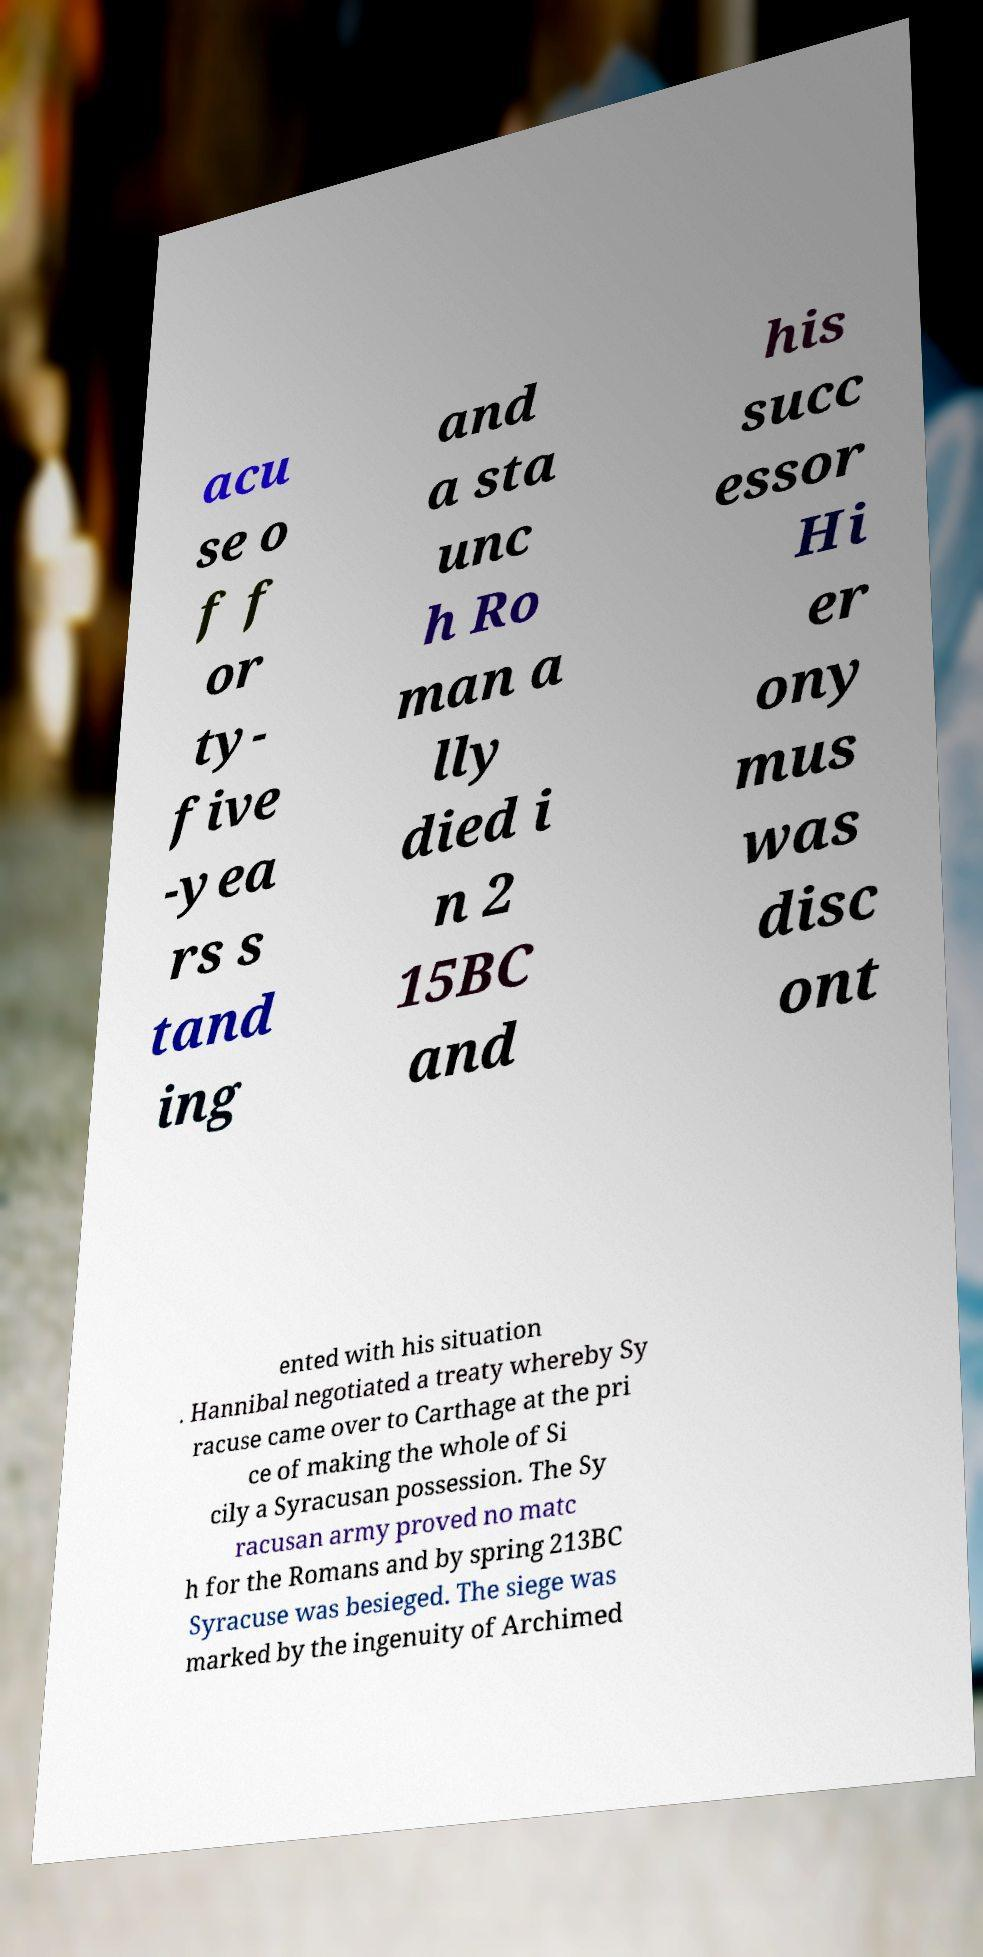For documentation purposes, I need the text within this image transcribed. Could you provide that? acu se o f f or ty- five -yea rs s tand ing and a sta unc h Ro man a lly died i n 2 15BC and his succ essor Hi er ony mus was disc ont ented with his situation . Hannibal negotiated a treaty whereby Sy racuse came over to Carthage at the pri ce of making the whole of Si cily a Syracusan possession. The Sy racusan army proved no matc h for the Romans and by spring 213BC Syracuse was besieged. The siege was marked by the ingenuity of Archimed 